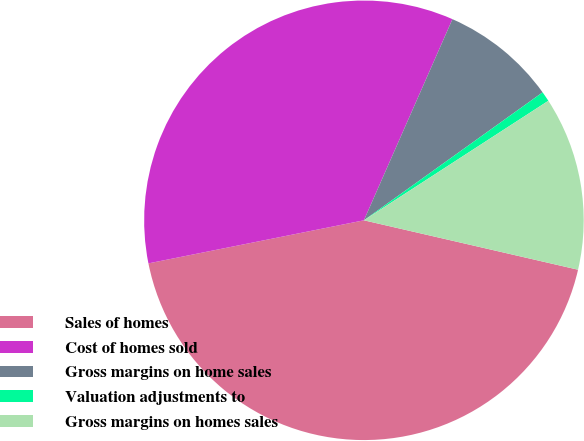<chart> <loc_0><loc_0><loc_500><loc_500><pie_chart><fcel>Sales of homes<fcel>Cost of homes sold<fcel>Gross margins on home sales<fcel>Valuation adjustments to<fcel>Gross margins on homes sales<nl><fcel>43.25%<fcel>34.74%<fcel>8.51%<fcel>0.74%<fcel>12.76%<nl></chart> 